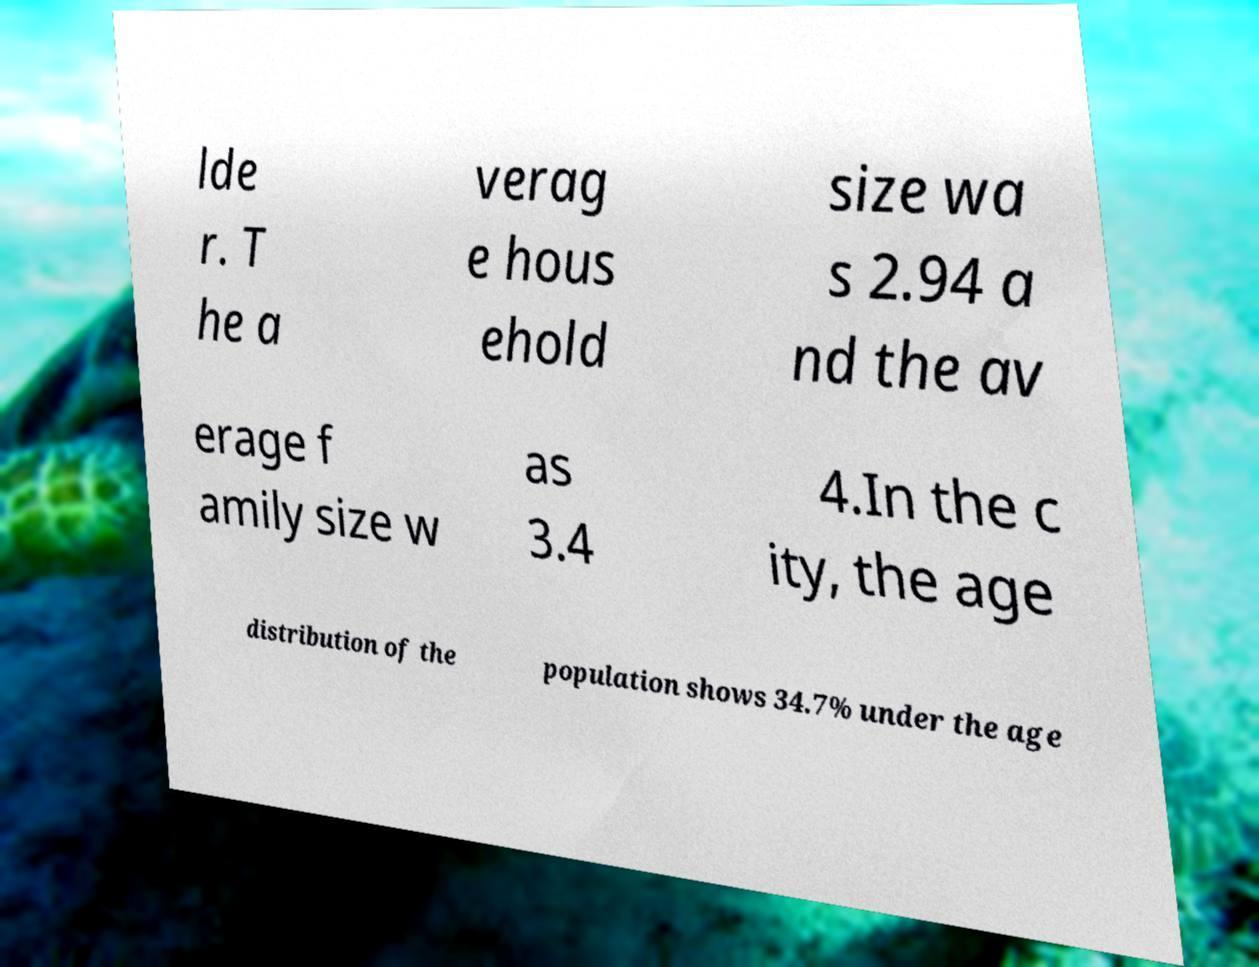For documentation purposes, I need the text within this image transcribed. Could you provide that? lde r. T he a verag e hous ehold size wa s 2.94 a nd the av erage f amily size w as 3.4 4.In the c ity, the age distribution of the population shows 34.7% under the age 